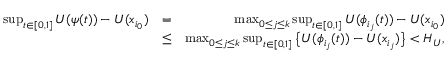Convert formula to latex. <formula><loc_0><loc_0><loc_500><loc_500>\begin{array} { r l r } { \sup _ { t \in [ 0 , 1 ] } U ( \psi ( t ) ) - U ( x _ { i _ { 0 } } ) } & { = } & { \max _ { 0 \leq j \leq k } \sup _ { t \in [ 0 , 1 ] } U ( \phi _ { i _ { j } } ( t ) ) - U ( x _ { i _ { 0 } } ) } \\ & { \leq } & { \max _ { 0 \leq j \leq k } \sup _ { t \in [ 0 , 1 ] } \left \{ U ( \phi _ { i _ { j } } ( t ) ) - U ( x _ { i _ { j } } ) \right \} < H _ { U } , } \end{array}</formula> 